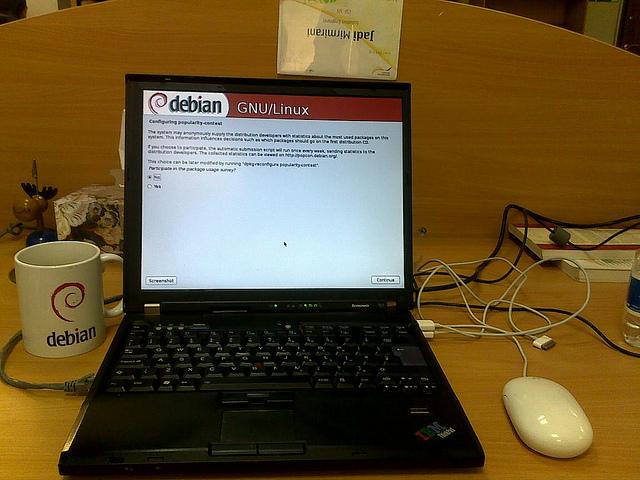What kind of computer is this?
Write a very short answer. Laptop. What does the person use the laptop for?
Quick response, please. Work. What brand is the computer?
Short answer required. Ibm. What color is the computer?
Be succinct. Black. What liquid is in the bottle?
Write a very short answer. Coffee. Does the drink have ice in it?
Quick response, please. No. What make is the laptop?
Quick response, please. Ibm. Are these wireless mice?
Short answer required. No. What kind of laptop is this?
Be succinct. Ibm. How much money does this person make when working with this computer?
Keep it brief. Little. What is to the right of the laptop?
Be succinct. Mouse. 